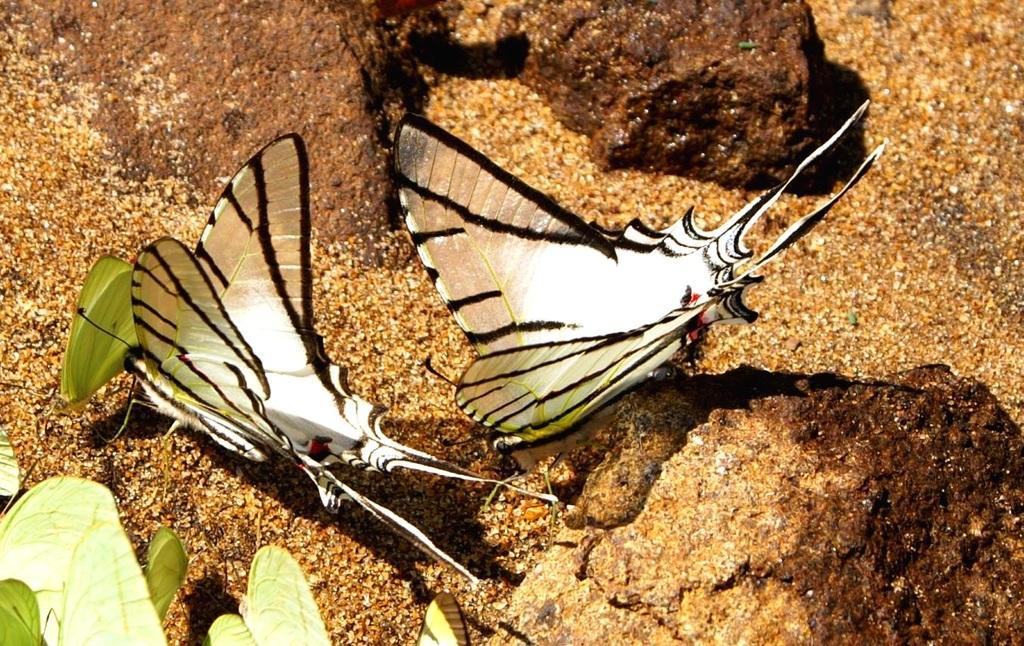In one or two sentences, can you explain what this image depicts? In this image in the center there are two butterflies, and in the background there is sand. At the bottom there are some leaves. 